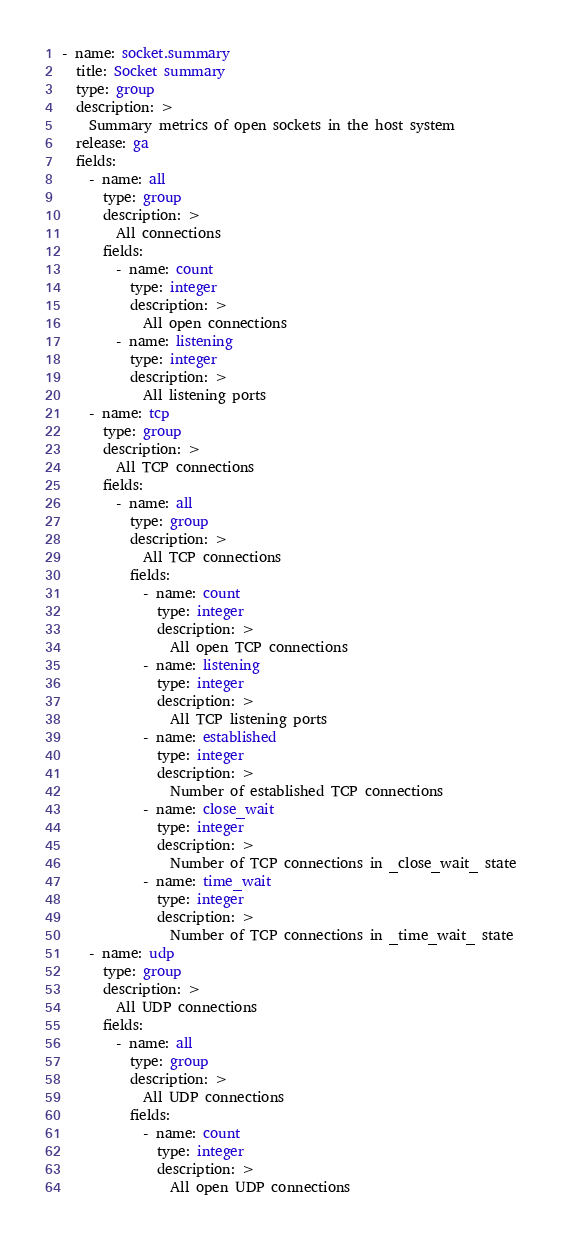Convert code to text. <code><loc_0><loc_0><loc_500><loc_500><_YAML_>- name: socket.summary
  title: Socket summary
  type: group
  description: >
    Summary metrics of open sockets in the host system
  release: ga
  fields:
    - name: all
      type: group
      description: >
        All connections
      fields:
        - name: count
          type: integer
          description: >
            All open connections
        - name: listening
          type: integer
          description: >
            All listening ports
    - name: tcp
      type: group
      description: >
        All TCP connections
      fields:
        - name: all
          type: group
          description: >
            All TCP connections
          fields:
            - name: count
              type: integer
              description: >
                All open TCP connections
            - name: listening
              type: integer
              description: >
                All TCP listening ports
            - name: established
              type: integer
              description: >
                Number of established TCP connections
            - name: close_wait
              type: integer
              description: >
                Number of TCP connections in _close_wait_ state
            - name: time_wait
              type: integer
              description: >
                Number of TCP connections in _time_wait_ state
    - name: udp
      type: group
      description: >
        All UDP connections
      fields:
        - name: all
          type: group
          description: >
            All UDP connections
          fields:
            - name: count
              type: integer
              description: >
                All open UDP connections



</code> 